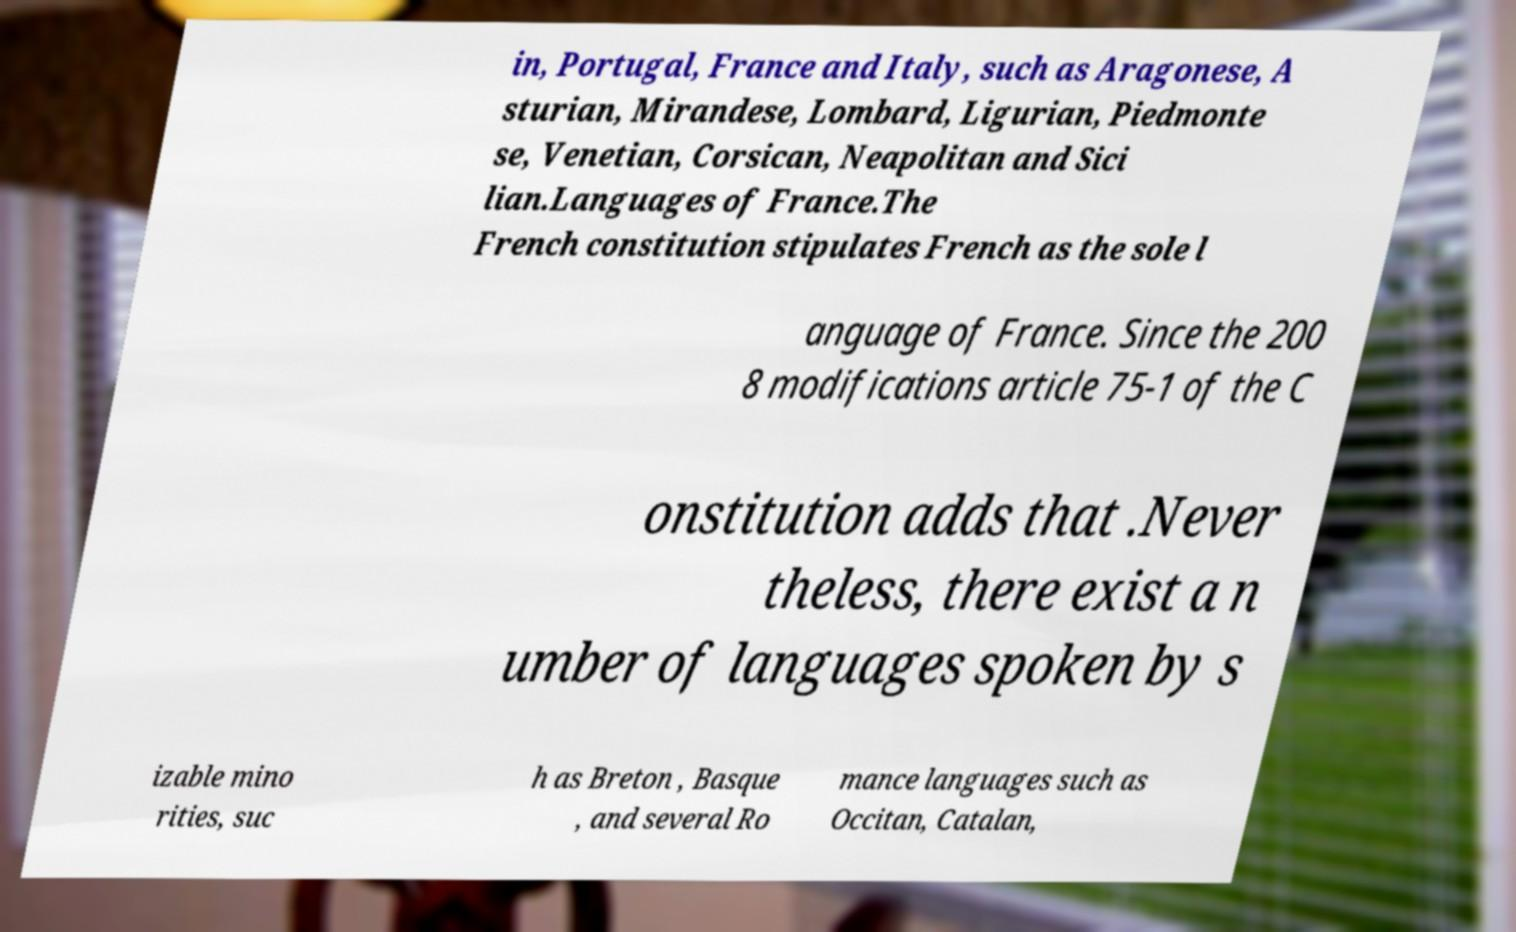Please identify and transcribe the text found in this image. in, Portugal, France and Italy, such as Aragonese, A sturian, Mirandese, Lombard, Ligurian, Piedmonte se, Venetian, Corsican, Neapolitan and Sici lian.Languages of France.The French constitution stipulates French as the sole l anguage of France. Since the 200 8 modifications article 75-1 of the C onstitution adds that .Never theless, there exist a n umber of languages spoken by s izable mino rities, suc h as Breton , Basque , and several Ro mance languages such as Occitan, Catalan, 